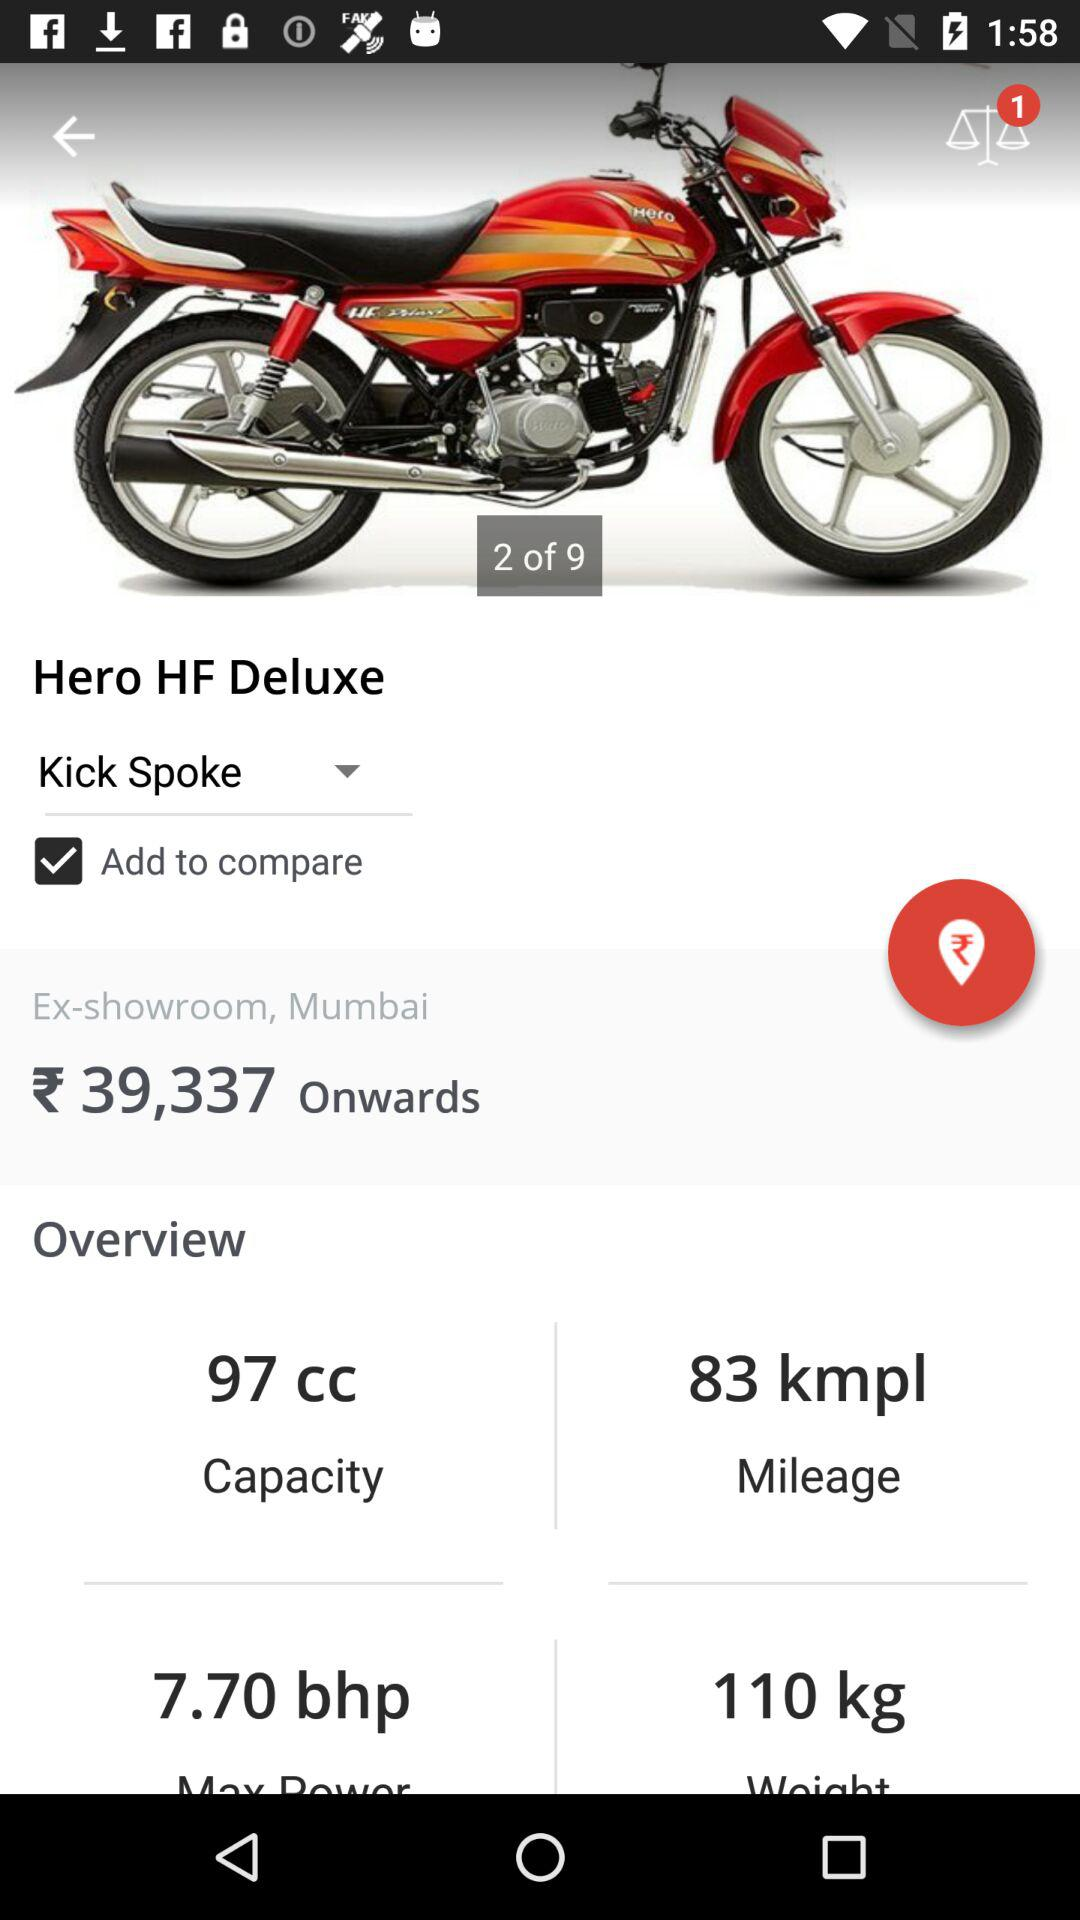Which parts are not included?
When the provided information is insufficient, respond with <no answer>. <no answer> 